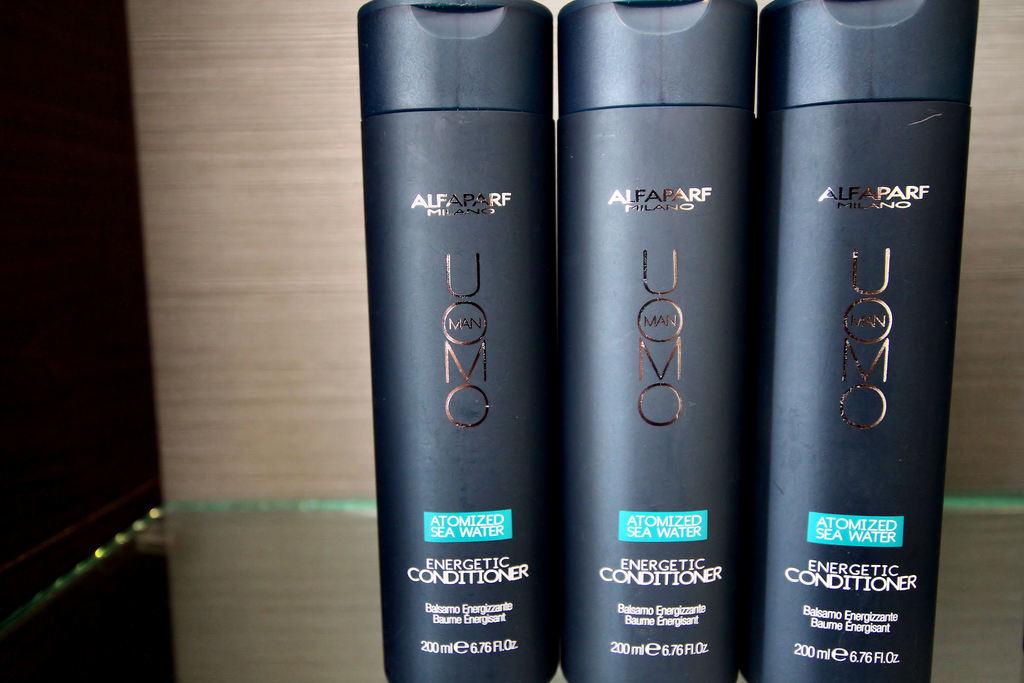What is the brand of conditioner?
Give a very brief answer. Uomo. How many ounces?
Provide a short and direct response. 6.76. 